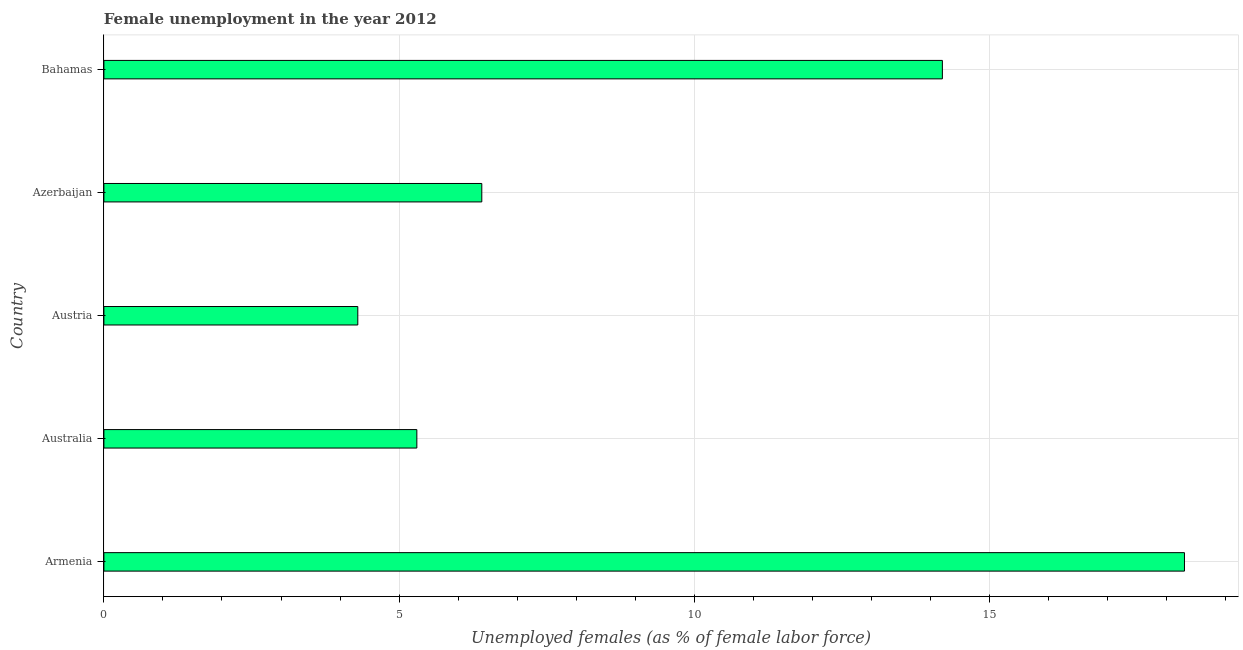Does the graph contain any zero values?
Keep it short and to the point. No. Does the graph contain grids?
Your answer should be compact. Yes. What is the title of the graph?
Keep it short and to the point. Female unemployment in the year 2012. What is the label or title of the X-axis?
Make the answer very short. Unemployed females (as % of female labor force). What is the label or title of the Y-axis?
Keep it short and to the point. Country. What is the unemployed females population in Austria?
Provide a succinct answer. 4.3. Across all countries, what is the maximum unemployed females population?
Your answer should be compact. 18.3. Across all countries, what is the minimum unemployed females population?
Keep it short and to the point. 4.3. In which country was the unemployed females population maximum?
Your answer should be very brief. Armenia. In which country was the unemployed females population minimum?
Keep it short and to the point. Austria. What is the sum of the unemployed females population?
Your response must be concise. 48.5. What is the median unemployed females population?
Provide a short and direct response. 6.4. What is the ratio of the unemployed females population in Australia to that in Austria?
Provide a short and direct response. 1.23. Is the unemployed females population in Armenia less than that in Australia?
Offer a very short reply. No. Is the difference between the unemployed females population in Armenia and Bahamas greater than the difference between any two countries?
Provide a succinct answer. No. What is the difference between the highest and the second highest unemployed females population?
Make the answer very short. 4.1. Is the sum of the unemployed females population in Armenia and Bahamas greater than the maximum unemployed females population across all countries?
Offer a very short reply. Yes. How many bars are there?
Your answer should be compact. 5. Are all the bars in the graph horizontal?
Keep it short and to the point. Yes. What is the difference between two consecutive major ticks on the X-axis?
Your answer should be compact. 5. What is the Unemployed females (as % of female labor force) in Armenia?
Offer a terse response. 18.3. What is the Unemployed females (as % of female labor force) in Australia?
Provide a succinct answer. 5.3. What is the Unemployed females (as % of female labor force) of Austria?
Your answer should be very brief. 4.3. What is the Unemployed females (as % of female labor force) of Azerbaijan?
Offer a terse response. 6.4. What is the Unemployed females (as % of female labor force) in Bahamas?
Provide a short and direct response. 14.2. What is the difference between the Unemployed females (as % of female labor force) in Armenia and Australia?
Offer a terse response. 13. What is the difference between the Unemployed females (as % of female labor force) in Armenia and Azerbaijan?
Give a very brief answer. 11.9. What is the difference between the Unemployed females (as % of female labor force) in Armenia and Bahamas?
Keep it short and to the point. 4.1. What is the difference between the Unemployed females (as % of female labor force) in Austria and Bahamas?
Your answer should be very brief. -9.9. What is the difference between the Unemployed females (as % of female labor force) in Azerbaijan and Bahamas?
Your response must be concise. -7.8. What is the ratio of the Unemployed females (as % of female labor force) in Armenia to that in Australia?
Offer a very short reply. 3.45. What is the ratio of the Unemployed females (as % of female labor force) in Armenia to that in Austria?
Offer a terse response. 4.26. What is the ratio of the Unemployed females (as % of female labor force) in Armenia to that in Azerbaijan?
Keep it short and to the point. 2.86. What is the ratio of the Unemployed females (as % of female labor force) in Armenia to that in Bahamas?
Provide a succinct answer. 1.29. What is the ratio of the Unemployed females (as % of female labor force) in Australia to that in Austria?
Make the answer very short. 1.23. What is the ratio of the Unemployed females (as % of female labor force) in Australia to that in Azerbaijan?
Make the answer very short. 0.83. What is the ratio of the Unemployed females (as % of female labor force) in Australia to that in Bahamas?
Keep it short and to the point. 0.37. What is the ratio of the Unemployed females (as % of female labor force) in Austria to that in Azerbaijan?
Keep it short and to the point. 0.67. What is the ratio of the Unemployed females (as % of female labor force) in Austria to that in Bahamas?
Offer a very short reply. 0.3. What is the ratio of the Unemployed females (as % of female labor force) in Azerbaijan to that in Bahamas?
Provide a short and direct response. 0.45. 